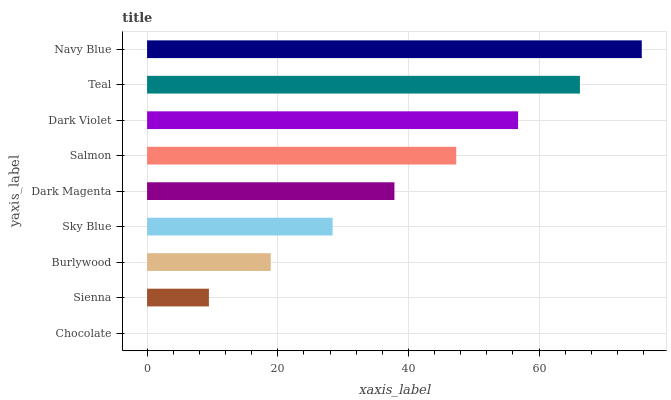Is Chocolate the minimum?
Answer yes or no. Yes. Is Navy Blue the maximum?
Answer yes or no. Yes. Is Sienna the minimum?
Answer yes or no. No. Is Sienna the maximum?
Answer yes or no. No. Is Sienna greater than Chocolate?
Answer yes or no. Yes. Is Chocolate less than Sienna?
Answer yes or no. Yes. Is Chocolate greater than Sienna?
Answer yes or no. No. Is Sienna less than Chocolate?
Answer yes or no. No. Is Dark Magenta the high median?
Answer yes or no. Yes. Is Dark Magenta the low median?
Answer yes or no. Yes. Is Burlywood the high median?
Answer yes or no. No. Is Salmon the low median?
Answer yes or no. No. 